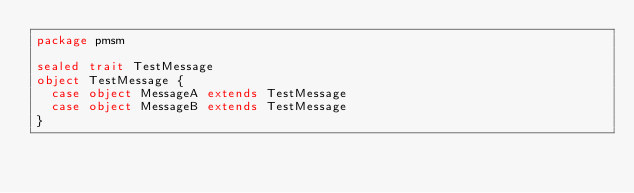Convert code to text. <code><loc_0><loc_0><loc_500><loc_500><_Scala_>package pmsm

sealed trait TestMessage
object TestMessage {
  case object MessageA extends TestMessage
  case object MessageB extends TestMessage
}
</code> 